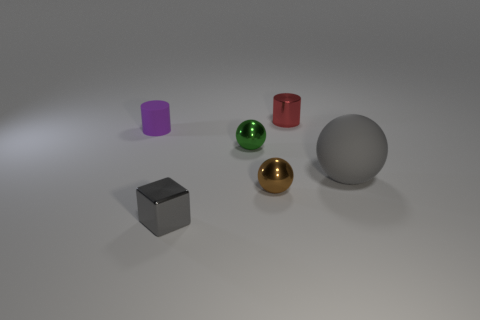There is a gray object to the right of the small metal cylinder; is its shape the same as the brown shiny thing?
Offer a terse response. Yes. There is a gray object that is left of the large ball; what shape is it?
Your answer should be very brief. Cube. What size is the ball that is the same color as the tiny cube?
Offer a terse response. Large. What is the tiny purple cylinder made of?
Give a very brief answer. Rubber. What is the color of the cylinder that is the same size as the purple rubber thing?
Offer a very short reply. Red. What is the shape of the small shiny object that is the same color as the large rubber sphere?
Provide a short and direct response. Cube. Is the small red thing the same shape as the purple rubber object?
Offer a terse response. Yes. What is the thing that is in front of the red metal thing and on the right side of the brown metallic object made of?
Give a very brief answer. Rubber. What is the size of the green sphere?
Your answer should be compact. Small. There is a rubber thing that is the same shape as the small red metal thing; what color is it?
Keep it short and to the point. Purple. 